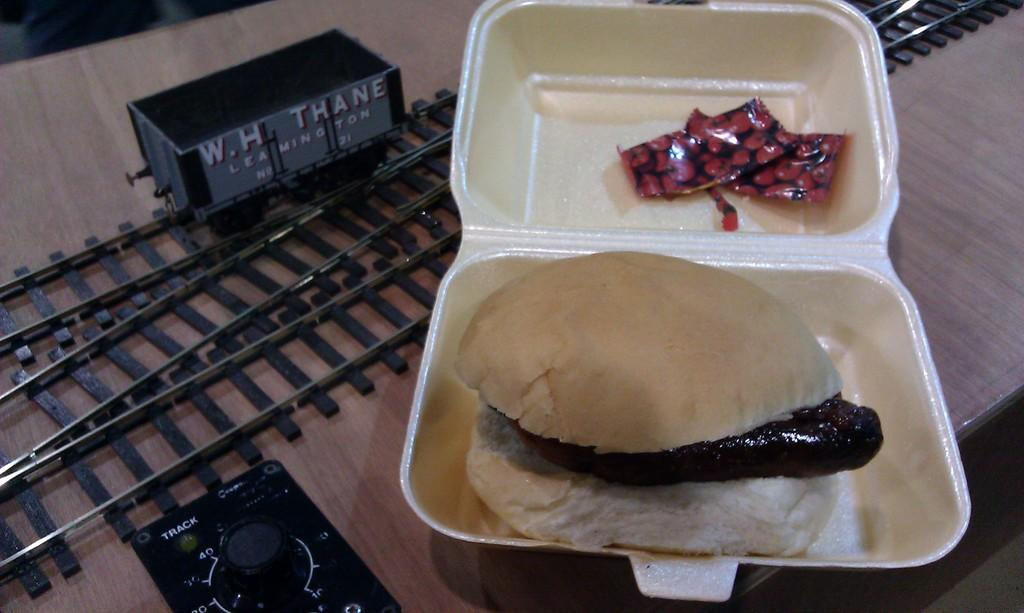What type of food is in the image? There is a burger in the image. How is the burger contained in the image? The burger is placed in a box. What color are the two objects beside the burger? The two objects beside the burger are red. What type of toy is in the image? There is a track toy in the image. What other objects can be seen beside the box? There are other objects beside the box. How many bears are sitting on the burger in the image? There are no bears present in the image, and therefore no bears are sitting on the burger. 